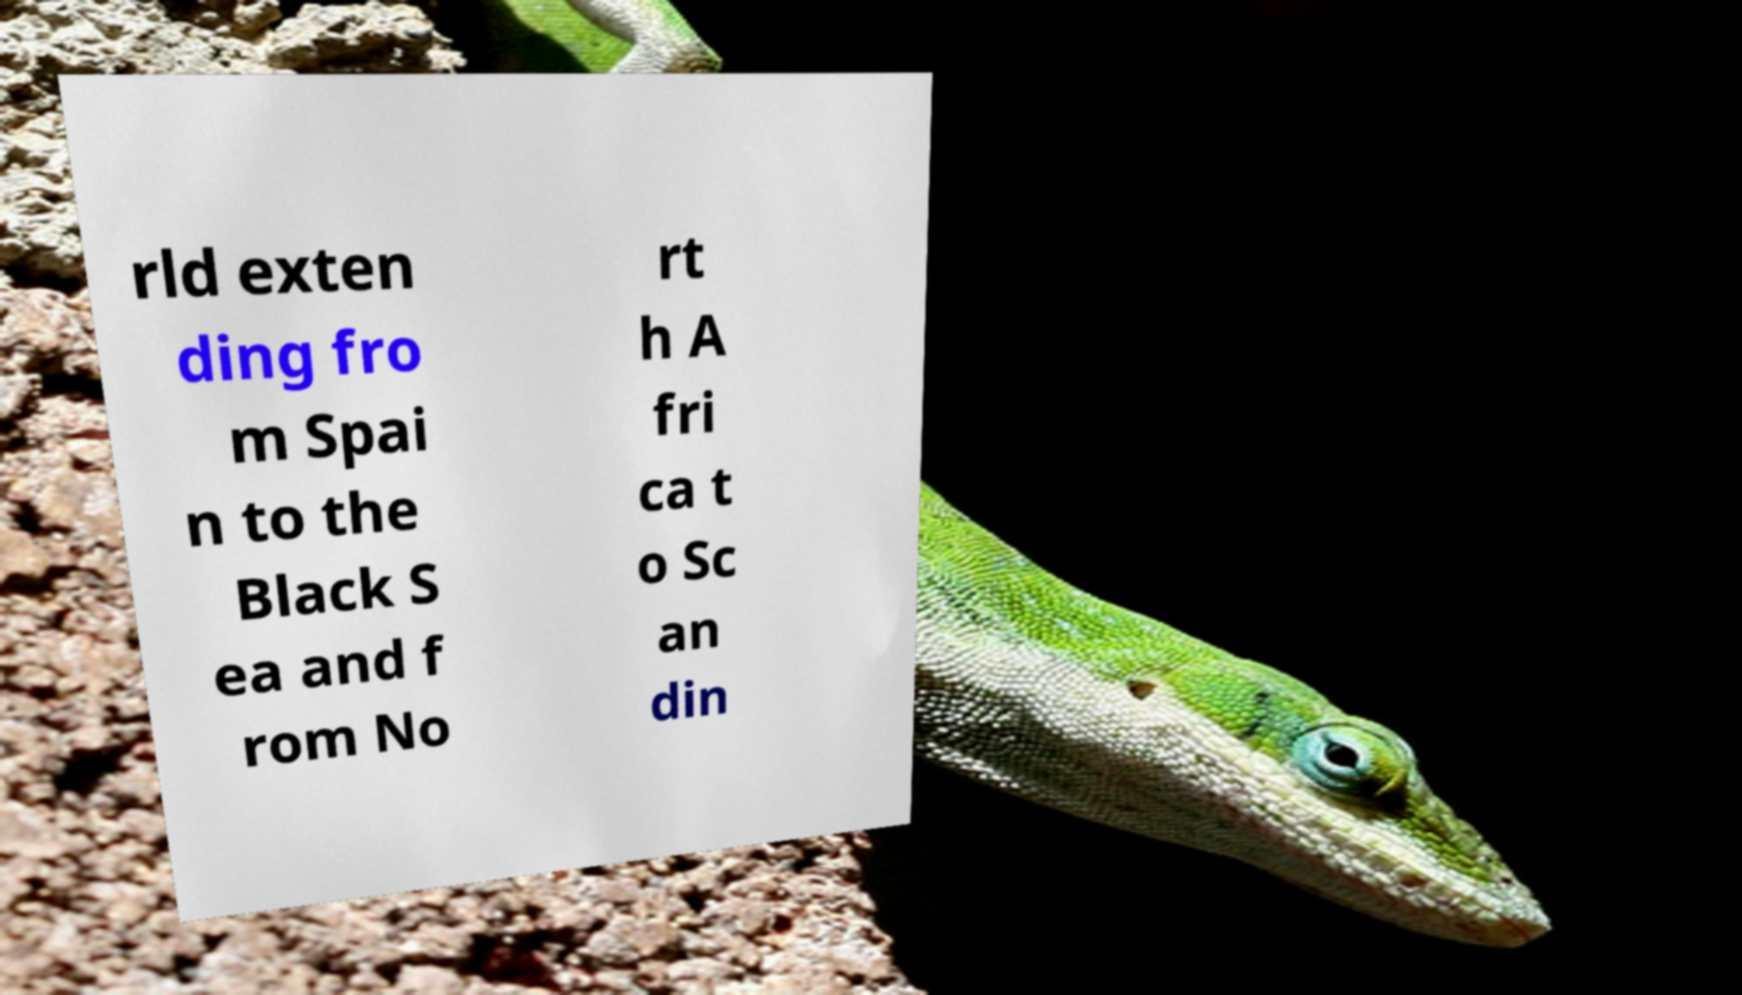Can you accurately transcribe the text from the provided image for me? rld exten ding fro m Spai n to the Black S ea and f rom No rt h A fri ca t o Sc an din 